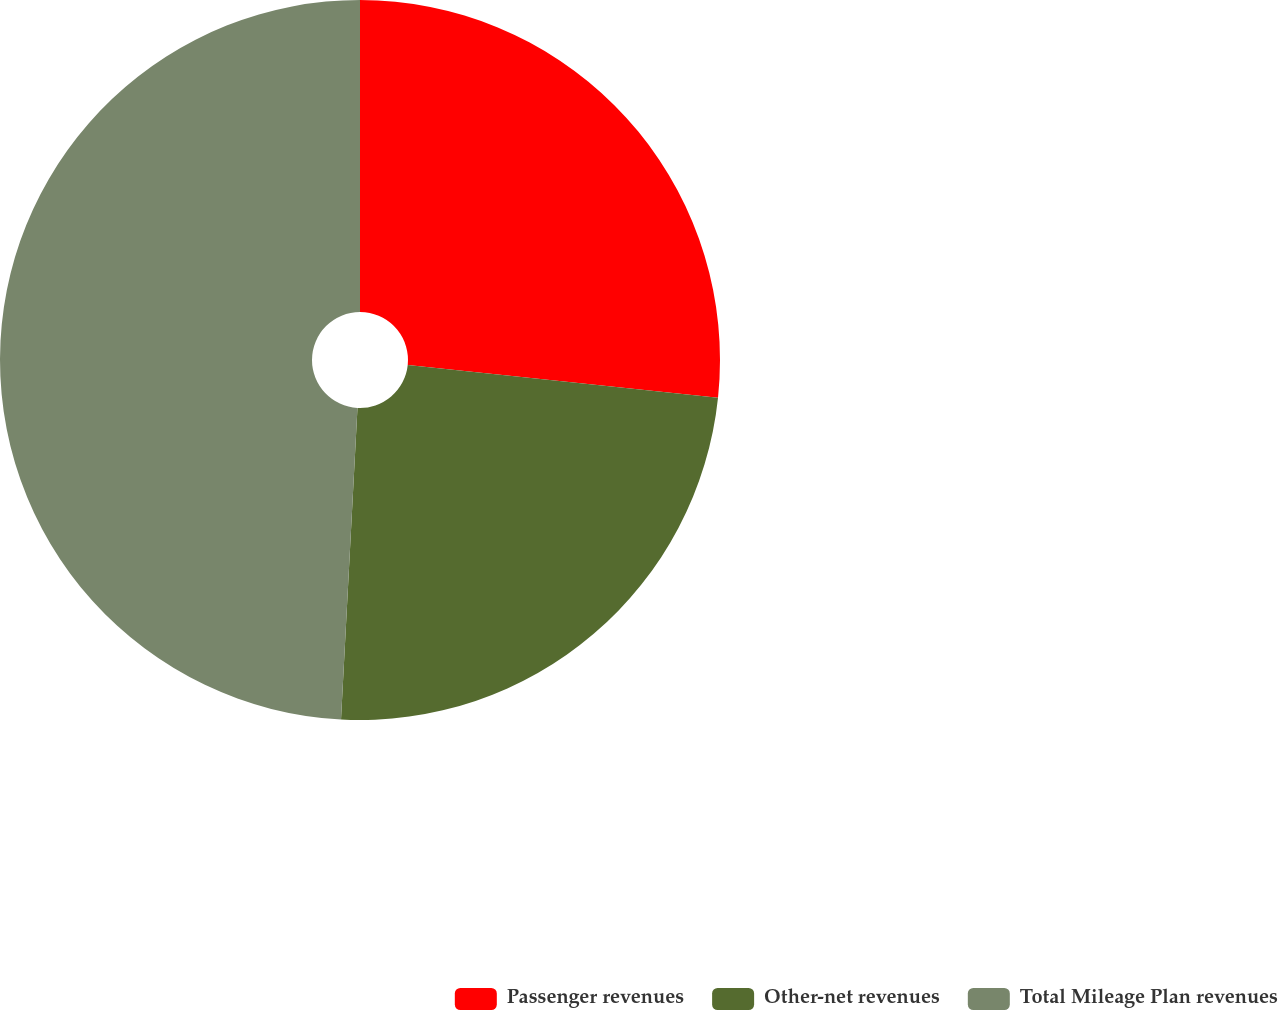Convert chart to OTSL. <chart><loc_0><loc_0><loc_500><loc_500><pie_chart><fcel>Passenger revenues<fcel>Other-net revenues<fcel>Total Mileage Plan revenues<nl><fcel>26.67%<fcel>24.17%<fcel>49.16%<nl></chart> 